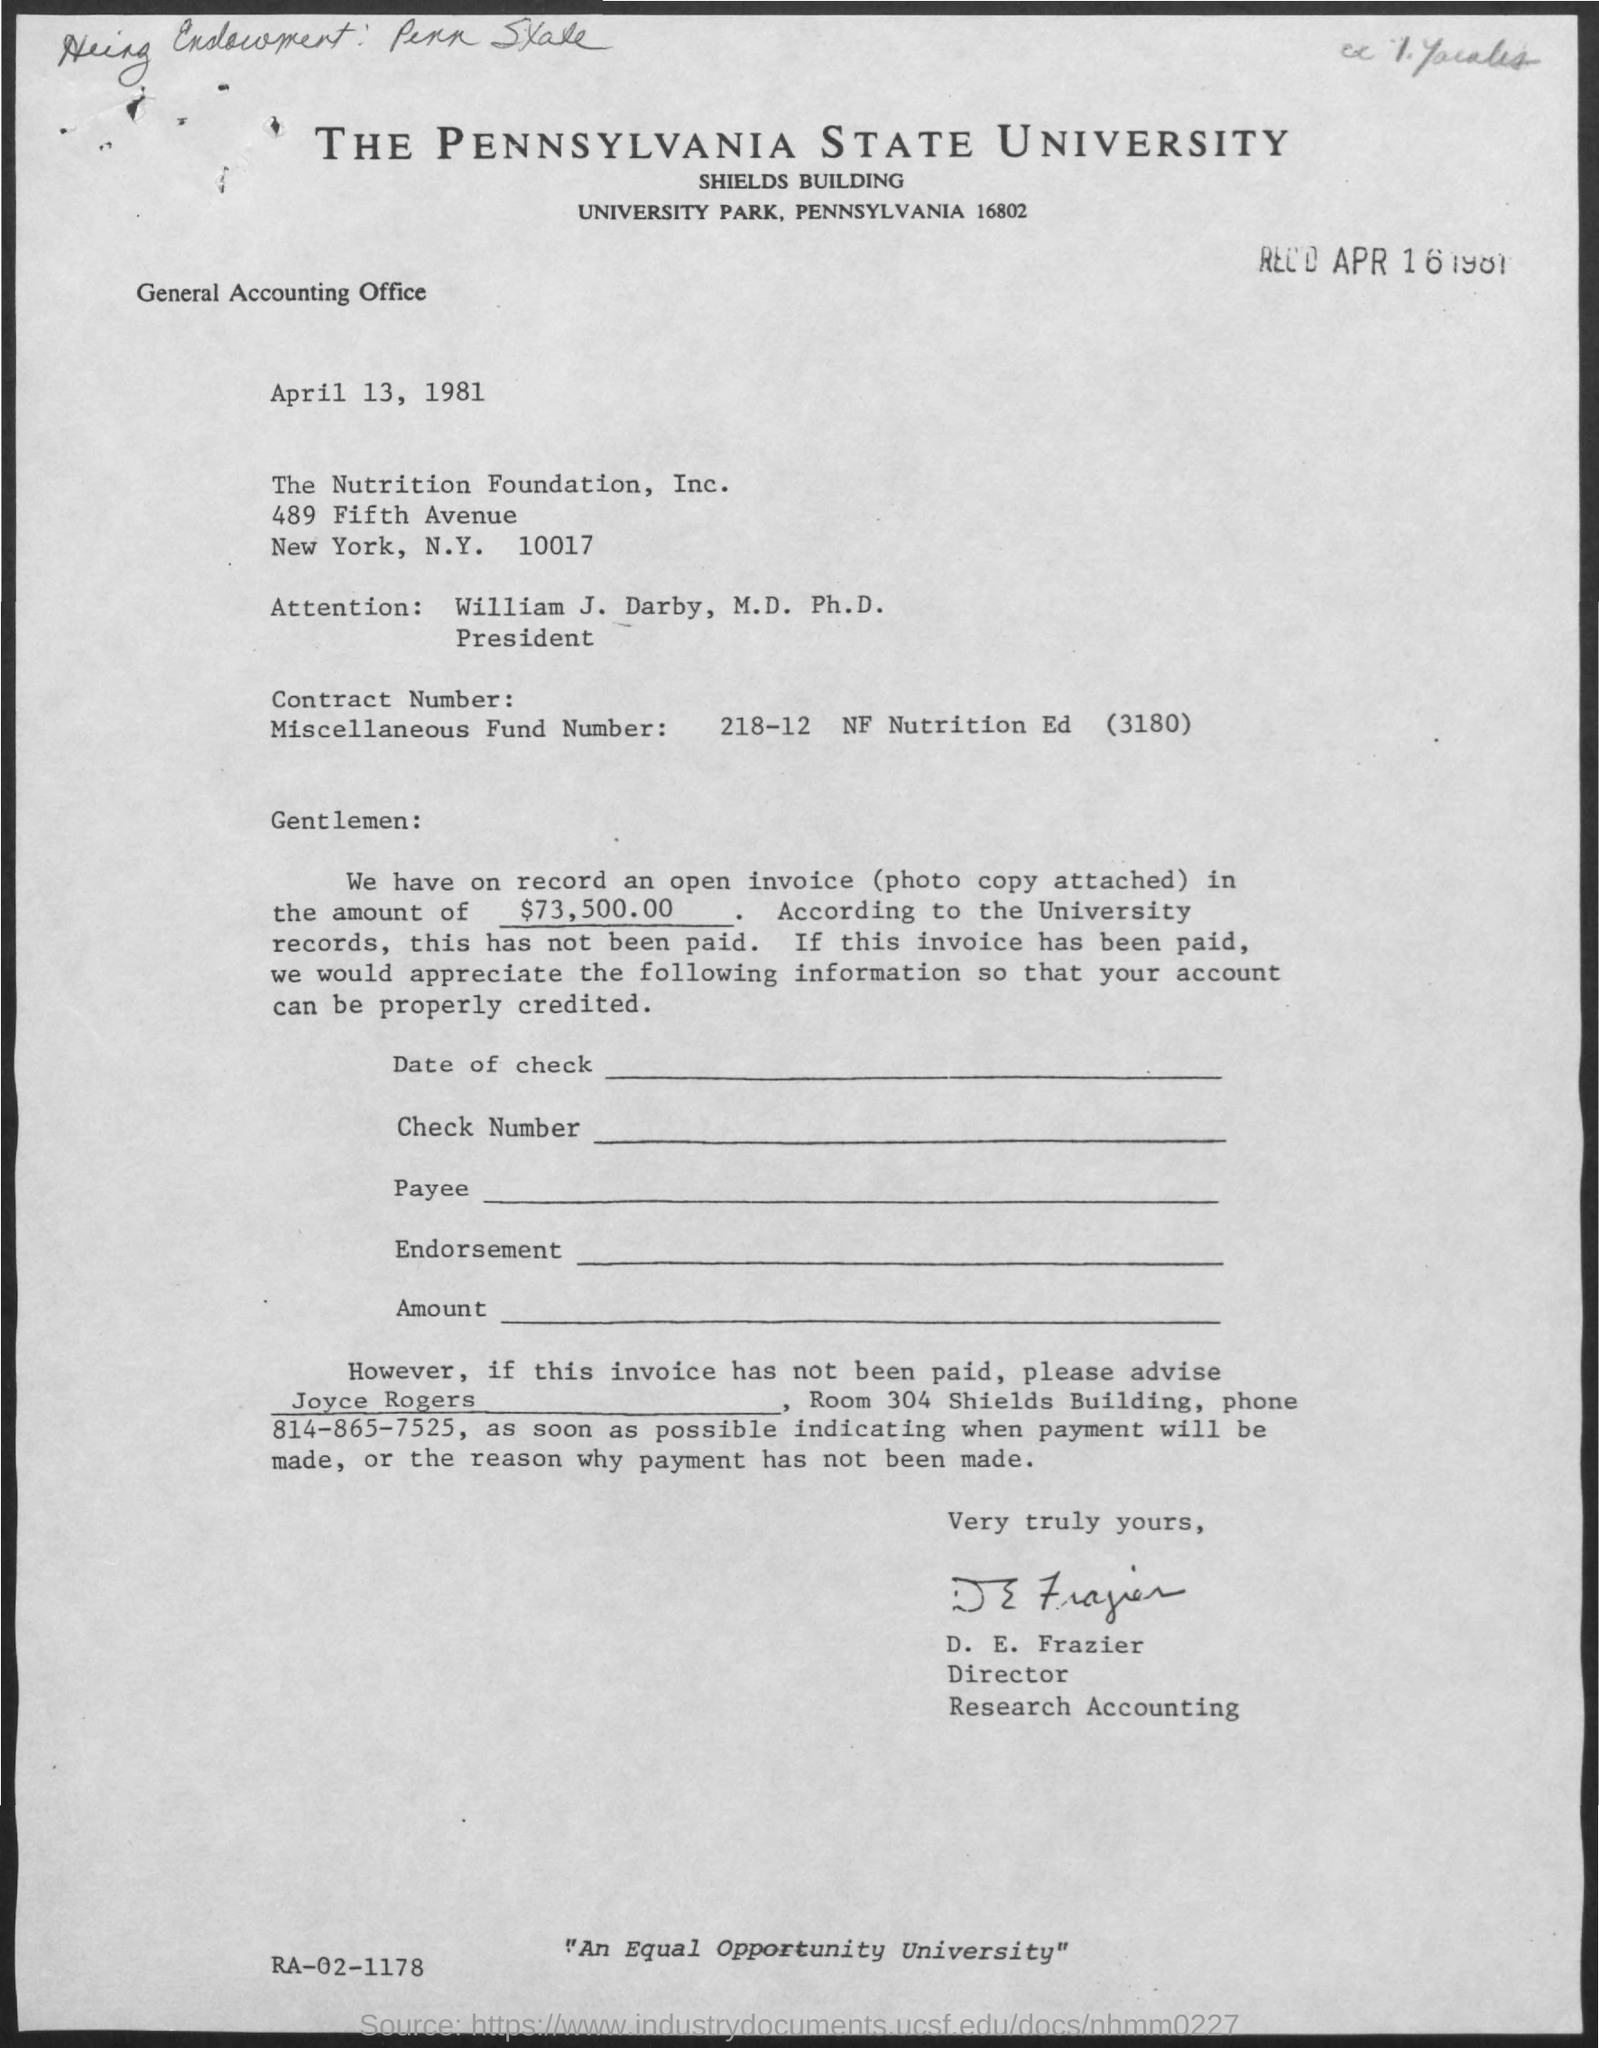What is the title of the document?
Your answer should be compact. The pennsylvania state university. 